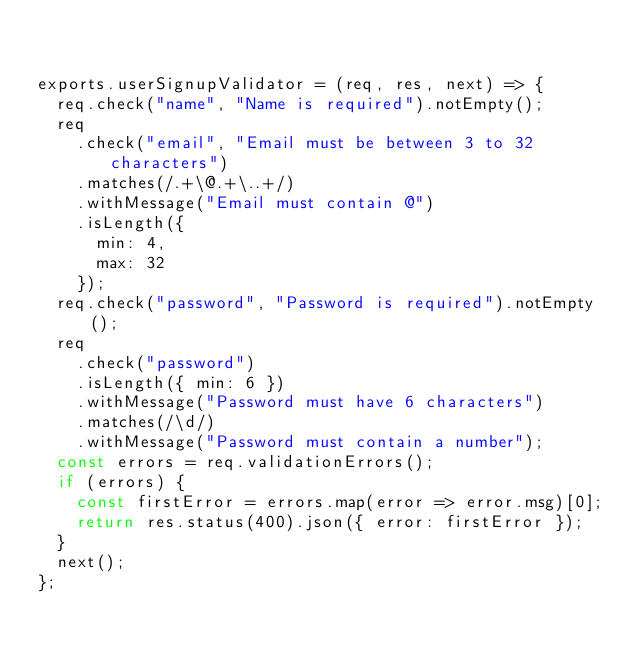Convert code to text. <code><loc_0><loc_0><loc_500><loc_500><_JavaScript_>  

exports.userSignupValidator = (req, res, next) => {
  req.check("name", "Name is required").notEmpty();
  req
    .check("email", "Email must be between 3 to 32 characters")
    .matches(/.+\@.+\..+/)
    .withMessage("Email must contain @")
    .isLength({
      min: 4,
      max: 32
    });
  req.check("password", "Password is required").notEmpty();
  req
    .check("password")
    .isLength({ min: 6 })
    .withMessage("Password must have 6 characters")
    .matches(/\d/)
    .withMessage("Password must contain a number");
  const errors = req.validationErrors();
  if (errors) {
    const firstError = errors.map(error => error.msg)[0];
    return res.status(400).json({ error: firstError });
  }
  next();
};</code> 